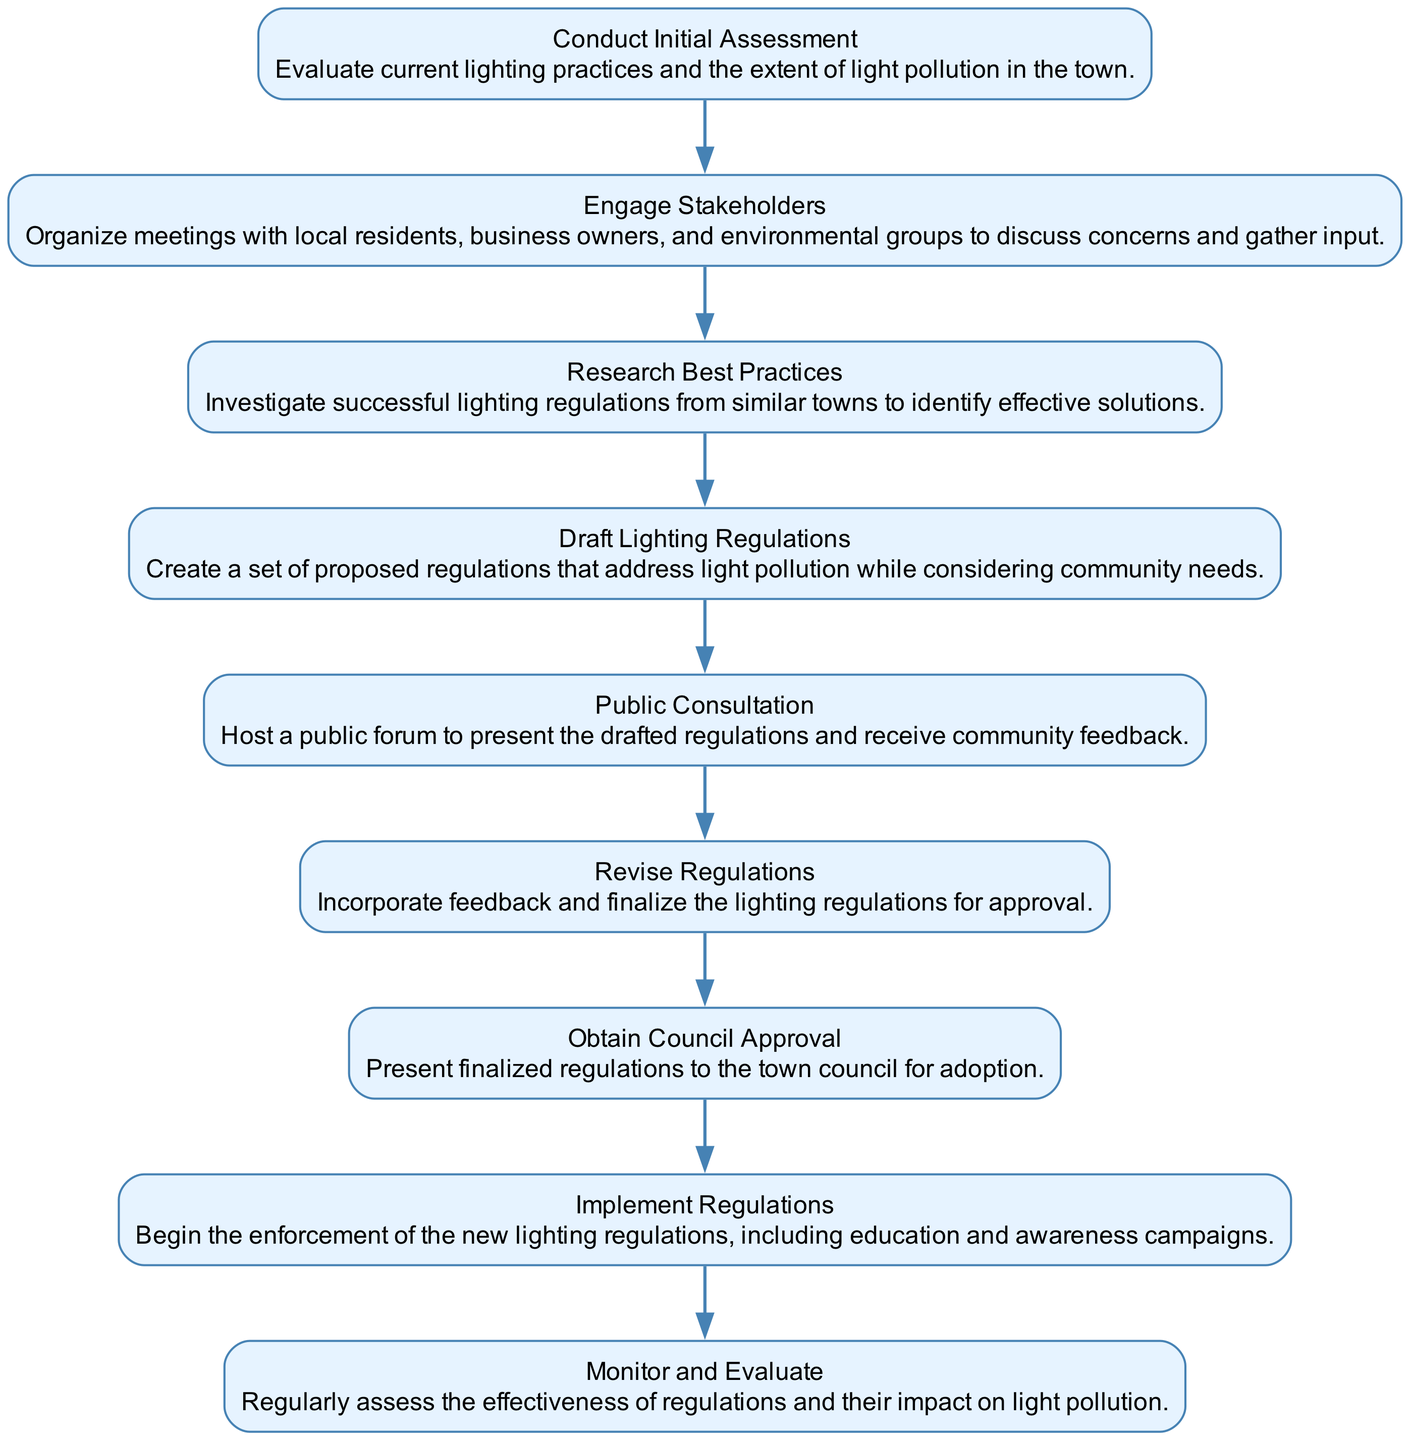What's the first step in the process? The first node in the flow chart represents the initial step, which is "Conduct Initial Assessment." This can be identified as it is the first node in the sequence without any incoming edges.
Answer: Conduct Initial Assessment How many steps are there in total? By counting the total number of nodes in the flow chart, we find that there are nine distinct steps, each corresponding to a specific stage in the lighting regulation process.
Answer: Nine What does the "Public Consultation" step involve? The node labeled "Public Consultation" describes that it involves hosting a public forum to present the drafted regulations and receive community feedback, as indicated directly in its description.
Answer: Host a public forum to present the drafted regulations and receive community feedback Which step follows "Obtain Council Approval"? Looking at the flow chart, the step that directly follows "Obtain Council Approval" is "Implement Regulations," as indicated by the directed edge connecting the two nodes sequentially.
Answer: Implement Regulations What is the purpose of the "Engage Stakeholders" step? The node "Engage Stakeholders" emphasizes organizing meetings with local residents, business owners, and environmental groups, which is described to discuss concerns and gather input, highlighting its collaborative purpose within the process.
Answer: Organize meetings with local residents, business owners, and environmental groups to discuss concerns and gather input How does "Revise Regulations" depend on prior steps? The "Revise Regulations" step relies on the "Public Consultation" step since it incorporates feedback received during the public forum to finalize the proposed lighting regulations. This dependency can be understood by tracing the directed edge from the public consultation node to the revision node.
Answer: It incorporates feedback from the Public Consultation step 